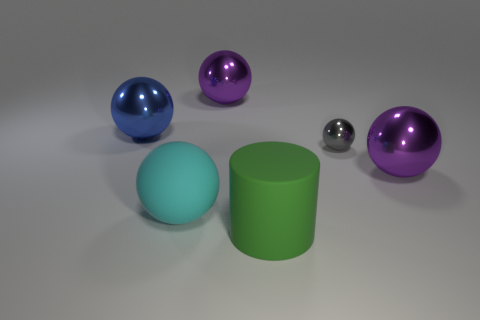There is a big metallic thing on the right side of the tiny gray sphere; what color is it?
Your answer should be very brief. Purple. What number of objects are either large purple spheres to the left of the green rubber cylinder or big green rubber objects?
Give a very brief answer. 2. What color is the other rubber object that is the same size as the green thing?
Your answer should be very brief. Cyan. Are there more big matte objects that are to the right of the large cyan matte thing than big green metal things?
Offer a terse response. Yes. The sphere that is on the right side of the large matte cylinder and in front of the small thing is made of what material?
Your answer should be very brief. Metal. There is a ball behind the large blue metal object; does it have the same color as the large object on the right side of the large cylinder?
Your answer should be compact. Yes. What number of other objects are the same size as the green thing?
Provide a succinct answer. 4. Are there any green rubber cylinders right of the big sphere that is behind the large blue shiny sphere behind the gray metallic ball?
Your answer should be very brief. Yes. Is the big purple sphere to the left of the big green object made of the same material as the tiny gray object?
Your answer should be compact. Yes. What is the color of the small metal thing that is the same shape as the cyan rubber thing?
Offer a terse response. Gray. 